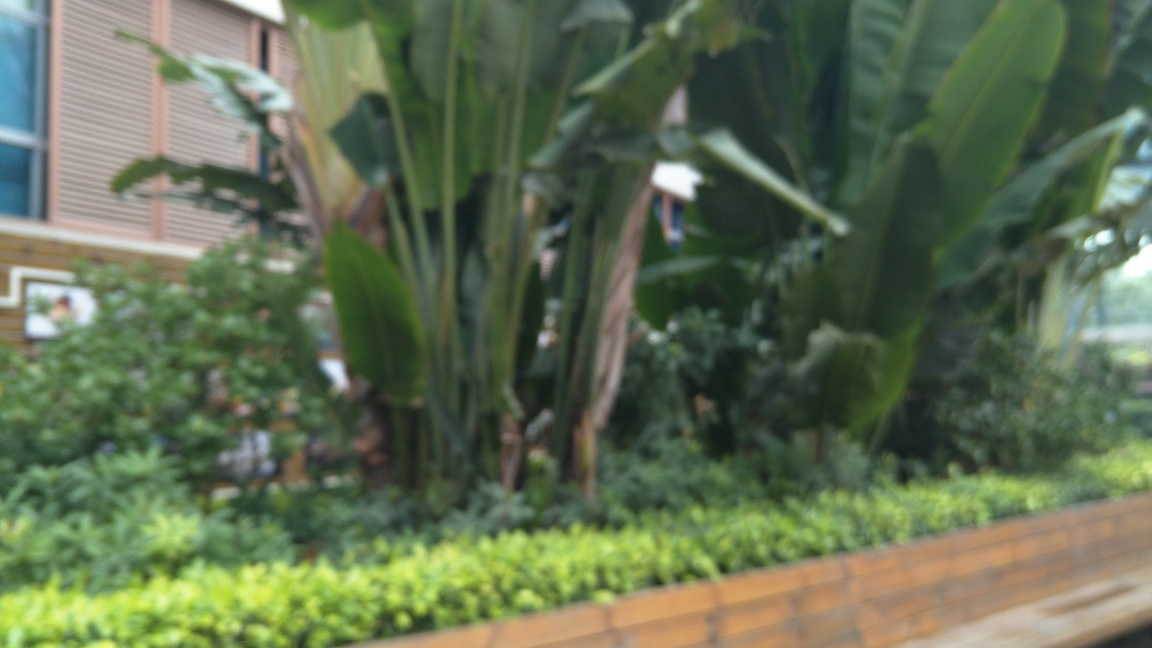What type of plants are dominating this blurred garden scene? Due to the focus issue, it's challenging to identify the plant species with precision. However, the overall structure and the visible leaves suggest that the dominant plants could be members of the banana family, possibly ornamental banana plants. These are often recognized by their large, paddle-shaped leaves and tall, sturdy stems. 